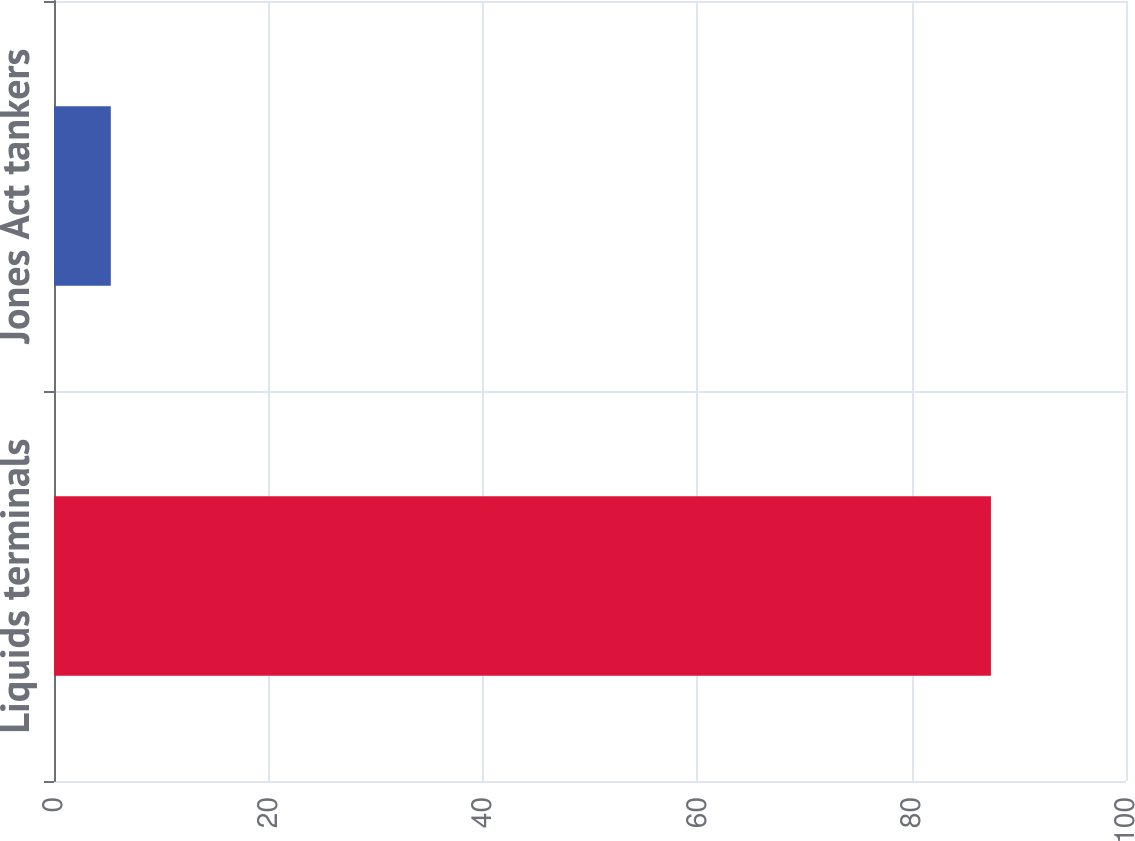Convert chart to OTSL. <chart><loc_0><loc_0><loc_500><loc_500><bar_chart><fcel>Liquids terminals<fcel>Jones Act tankers<nl><fcel>87.4<fcel>5.3<nl></chart> 